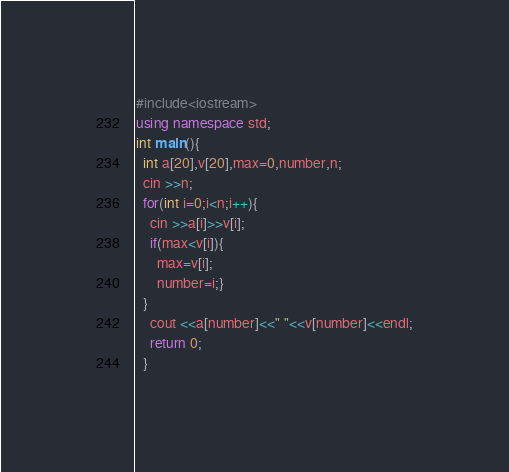Convert code to text. <code><loc_0><loc_0><loc_500><loc_500><_C++_>#include<iostream>
using namespace std;
int main(){
  int a[20],v[20],max=0,number,n;
  cin >>n;
  for(int i=0;i<n;i++){
    cin >>a[i]>>v[i];
    if(max<v[i]){
      max=v[i];
      number=i;}
  }
    cout <<a[number]<<" "<<v[number]<<endl;
    return 0;
  }</code> 